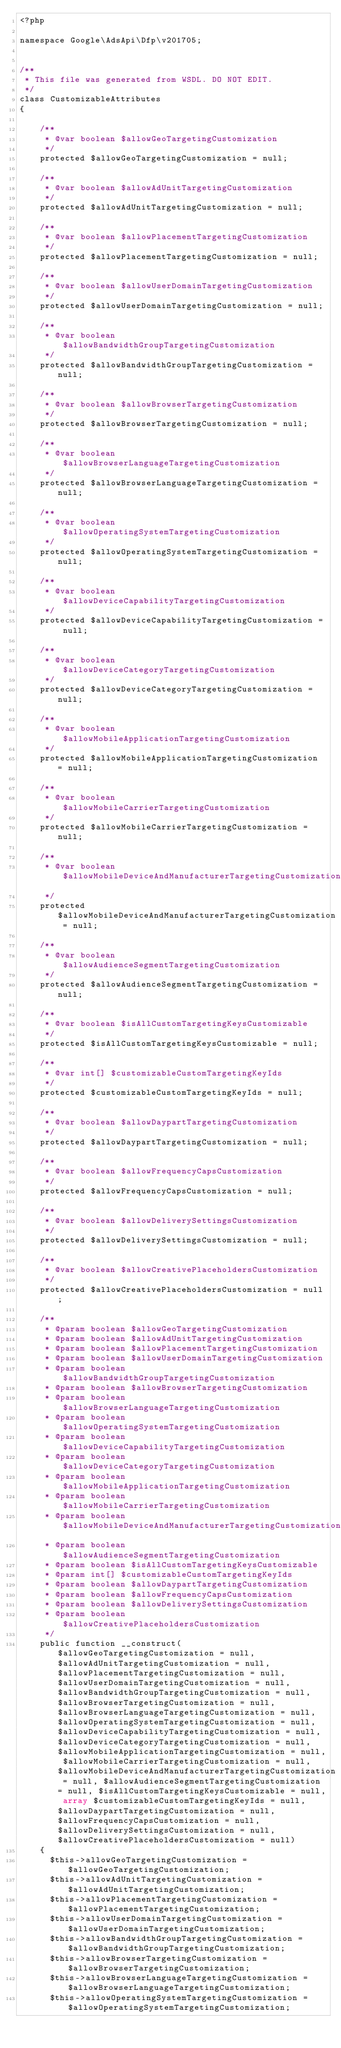Convert code to text. <code><loc_0><loc_0><loc_500><loc_500><_PHP_><?php

namespace Google\AdsApi\Dfp\v201705;


/**
 * This file was generated from WSDL. DO NOT EDIT.
 */
class CustomizableAttributes
{

    /**
     * @var boolean $allowGeoTargetingCustomization
     */
    protected $allowGeoTargetingCustomization = null;

    /**
     * @var boolean $allowAdUnitTargetingCustomization
     */
    protected $allowAdUnitTargetingCustomization = null;

    /**
     * @var boolean $allowPlacementTargetingCustomization
     */
    protected $allowPlacementTargetingCustomization = null;

    /**
     * @var boolean $allowUserDomainTargetingCustomization
     */
    protected $allowUserDomainTargetingCustomization = null;

    /**
     * @var boolean $allowBandwidthGroupTargetingCustomization
     */
    protected $allowBandwidthGroupTargetingCustomization = null;

    /**
     * @var boolean $allowBrowserTargetingCustomization
     */
    protected $allowBrowserTargetingCustomization = null;

    /**
     * @var boolean $allowBrowserLanguageTargetingCustomization
     */
    protected $allowBrowserLanguageTargetingCustomization = null;

    /**
     * @var boolean $allowOperatingSystemTargetingCustomization
     */
    protected $allowOperatingSystemTargetingCustomization = null;

    /**
     * @var boolean $allowDeviceCapabilityTargetingCustomization
     */
    protected $allowDeviceCapabilityTargetingCustomization = null;

    /**
     * @var boolean $allowDeviceCategoryTargetingCustomization
     */
    protected $allowDeviceCategoryTargetingCustomization = null;

    /**
     * @var boolean $allowMobileApplicationTargetingCustomization
     */
    protected $allowMobileApplicationTargetingCustomization = null;

    /**
     * @var boolean $allowMobileCarrierTargetingCustomization
     */
    protected $allowMobileCarrierTargetingCustomization = null;

    /**
     * @var boolean $allowMobileDeviceAndManufacturerTargetingCustomization
     */
    protected $allowMobileDeviceAndManufacturerTargetingCustomization = null;

    /**
     * @var boolean $allowAudienceSegmentTargetingCustomization
     */
    protected $allowAudienceSegmentTargetingCustomization = null;

    /**
     * @var boolean $isAllCustomTargetingKeysCustomizable
     */
    protected $isAllCustomTargetingKeysCustomizable = null;

    /**
     * @var int[] $customizableCustomTargetingKeyIds
     */
    protected $customizableCustomTargetingKeyIds = null;

    /**
     * @var boolean $allowDaypartTargetingCustomization
     */
    protected $allowDaypartTargetingCustomization = null;

    /**
     * @var boolean $allowFrequencyCapsCustomization
     */
    protected $allowFrequencyCapsCustomization = null;

    /**
     * @var boolean $allowDeliverySettingsCustomization
     */
    protected $allowDeliverySettingsCustomization = null;

    /**
     * @var boolean $allowCreativePlaceholdersCustomization
     */
    protected $allowCreativePlaceholdersCustomization = null;

    /**
     * @param boolean $allowGeoTargetingCustomization
     * @param boolean $allowAdUnitTargetingCustomization
     * @param boolean $allowPlacementTargetingCustomization
     * @param boolean $allowUserDomainTargetingCustomization
     * @param boolean $allowBandwidthGroupTargetingCustomization
     * @param boolean $allowBrowserTargetingCustomization
     * @param boolean $allowBrowserLanguageTargetingCustomization
     * @param boolean $allowOperatingSystemTargetingCustomization
     * @param boolean $allowDeviceCapabilityTargetingCustomization
     * @param boolean $allowDeviceCategoryTargetingCustomization
     * @param boolean $allowMobileApplicationTargetingCustomization
     * @param boolean $allowMobileCarrierTargetingCustomization
     * @param boolean $allowMobileDeviceAndManufacturerTargetingCustomization
     * @param boolean $allowAudienceSegmentTargetingCustomization
     * @param boolean $isAllCustomTargetingKeysCustomizable
     * @param int[] $customizableCustomTargetingKeyIds
     * @param boolean $allowDaypartTargetingCustomization
     * @param boolean $allowFrequencyCapsCustomization
     * @param boolean $allowDeliverySettingsCustomization
     * @param boolean $allowCreativePlaceholdersCustomization
     */
    public function __construct($allowGeoTargetingCustomization = null, $allowAdUnitTargetingCustomization = null, $allowPlacementTargetingCustomization = null, $allowUserDomainTargetingCustomization = null, $allowBandwidthGroupTargetingCustomization = null, $allowBrowserTargetingCustomization = null, $allowBrowserLanguageTargetingCustomization = null, $allowOperatingSystemTargetingCustomization = null, $allowDeviceCapabilityTargetingCustomization = null, $allowDeviceCategoryTargetingCustomization = null, $allowMobileApplicationTargetingCustomization = null, $allowMobileCarrierTargetingCustomization = null, $allowMobileDeviceAndManufacturerTargetingCustomization = null, $allowAudienceSegmentTargetingCustomization = null, $isAllCustomTargetingKeysCustomizable = null, array $customizableCustomTargetingKeyIds = null, $allowDaypartTargetingCustomization = null, $allowFrequencyCapsCustomization = null, $allowDeliverySettingsCustomization = null, $allowCreativePlaceholdersCustomization = null)
    {
      $this->allowGeoTargetingCustomization = $allowGeoTargetingCustomization;
      $this->allowAdUnitTargetingCustomization = $allowAdUnitTargetingCustomization;
      $this->allowPlacementTargetingCustomization = $allowPlacementTargetingCustomization;
      $this->allowUserDomainTargetingCustomization = $allowUserDomainTargetingCustomization;
      $this->allowBandwidthGroupTargetingCustomization = $allowBandwidthGroupTargetingCustomization;
      $this->allowBrowserTargetingCustomization = $allowBrowserTargetingCustomization;
      $this->allowBrowserLanguageTargetingCustomization = $allowBrowserLanguageTargetingCustomization;
      $this->allowOperatingSystemTargetingCustomization = $allowOperatingSystemTargetingCustomization;</code> 